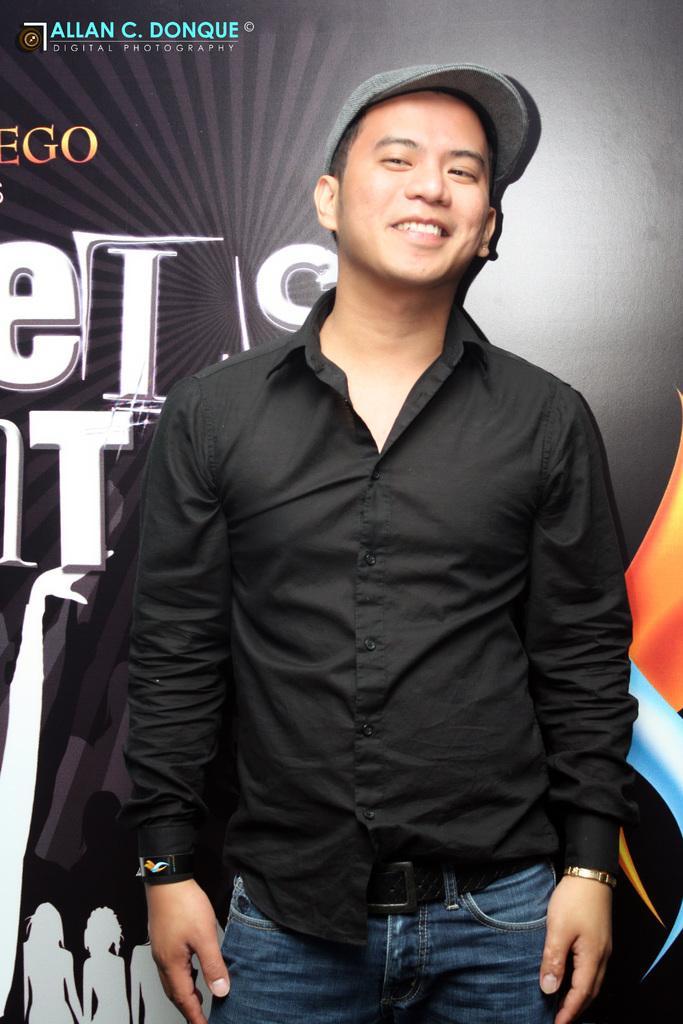Describe this image in one or two sentences. In this image a man wearing black shirt , jeans, cap is smiling. He is standing in front of a banner. 